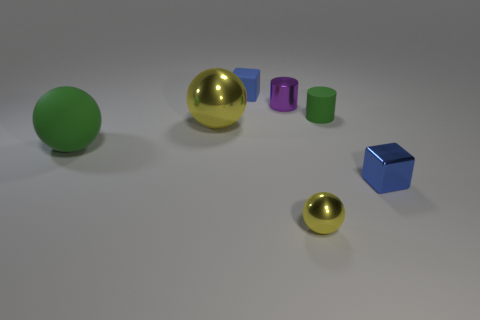Subtract all metallic balls. How many balls are left? 1 Subtract 1 cubes. How many cubes are left? 1 Subtract all yellow balls. How many balls are left? 1 Subtract all spheres. How many objects are left? 4 Subtract all large yellow metallic things. Subtract all blue matte blocks. How many objects are left? 5 Add 3 yellow metal objects. How many yellow metal objects are left? 5 Add 4 small metal things. How many small metal things exist? 7 Add 3 small purple balls. How many objects exist? 10 Subtract 0 blue spheres. How many objects are left? 7 Subtract all yellow cylinders. Subtract all gray cubes. How many cylinders are left? 2 